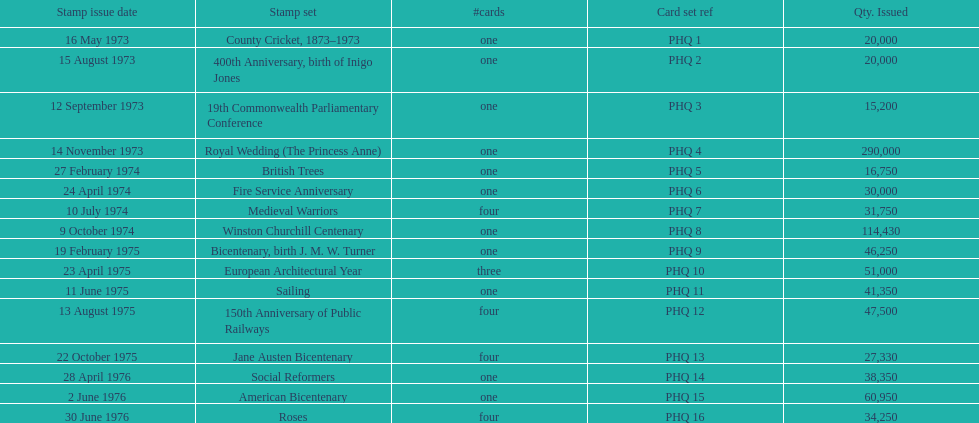Which card has the greatest number of issuances? Royal Wedding (The Princess Anne). 